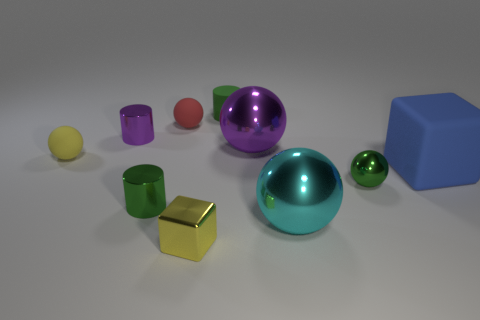Which object seems like it could roll the farthest if pushed? If pushed, the largest teal sphere seems like it would roll the farthest due to its smooth and symmetrical shape, which allows for minimal friction and sustained movement. 